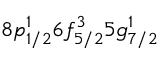<formula> <loc_0><loc_0><loc_500><loc_500>8 p _ { 1 / 2 } ^ { 1 } 6 f _ { 5 / 2 } ^ { 3 } 5 g _ { 7 / 2 } ^ { 1 }</formula> 